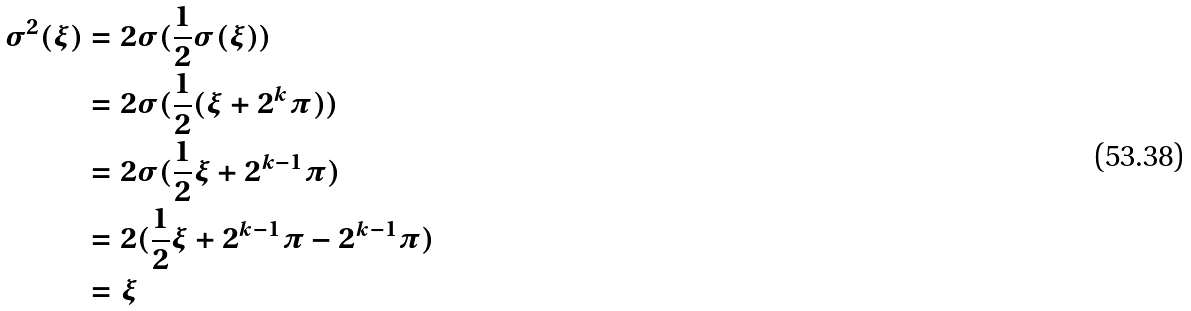<formula> <loc_0><loc_0><loc_500><loc_500>\sigma ^ { 2 } ( \xi ) & = 2 \sigma ( \frac { 1 } { 2 } \sigma ( \xi ) ) \\ & = 2 \sigma ( \frac { 1 } { 2 } ( \xi + 2 ^ { k } \pi ) ) \\ & = 2 \sigma ( \frac { 1 } { 2 } \xi + 2 ^ { k - 1 } \pi ) \\ & = 2 ( \frac { 1 } { 2 } \xi + 2 ^ { k - 1 } \pi - 2 ^ { k - 1 } \pi ) \\ & = \xi</formula> 